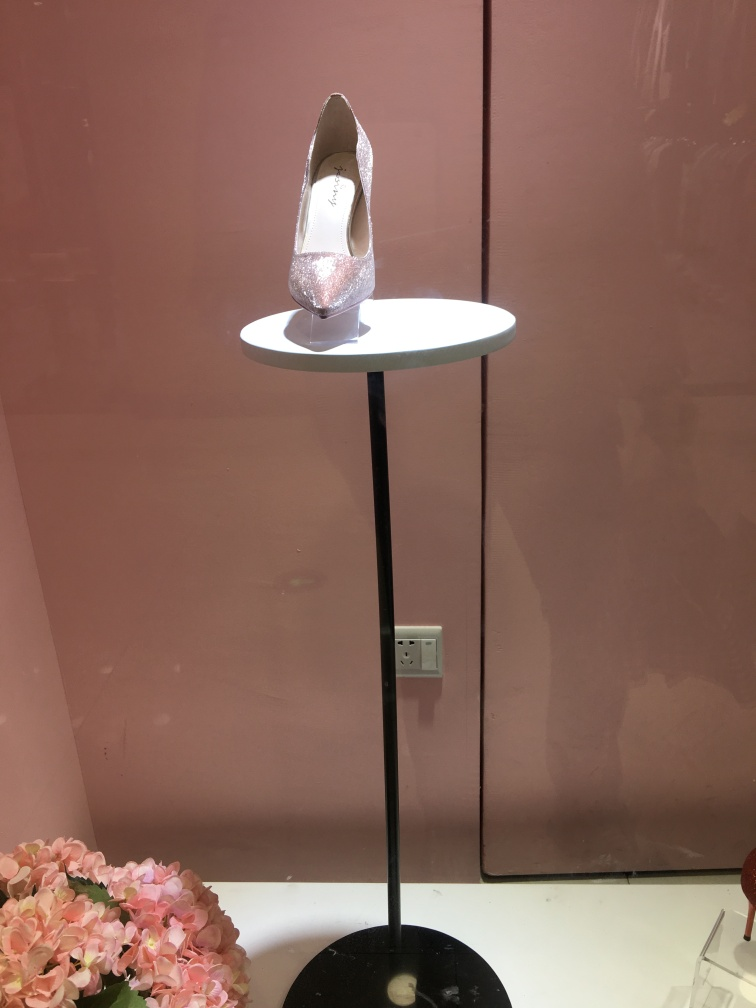What type of setting does this shoe seem to be in? The shoe is presented in a display environment, likely within a retail or boutique store, where its design can be showcased against a neutral and slightly reflective background. The strategic placement and lighting suggest that it is meant to attract attention to the shimmering detail and elegant design of the shoe. 